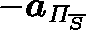<formula> <loc_0><loc_0><loc_500><loc_500>- a _ { \Pi _ { \overline { S } } }</formula> 